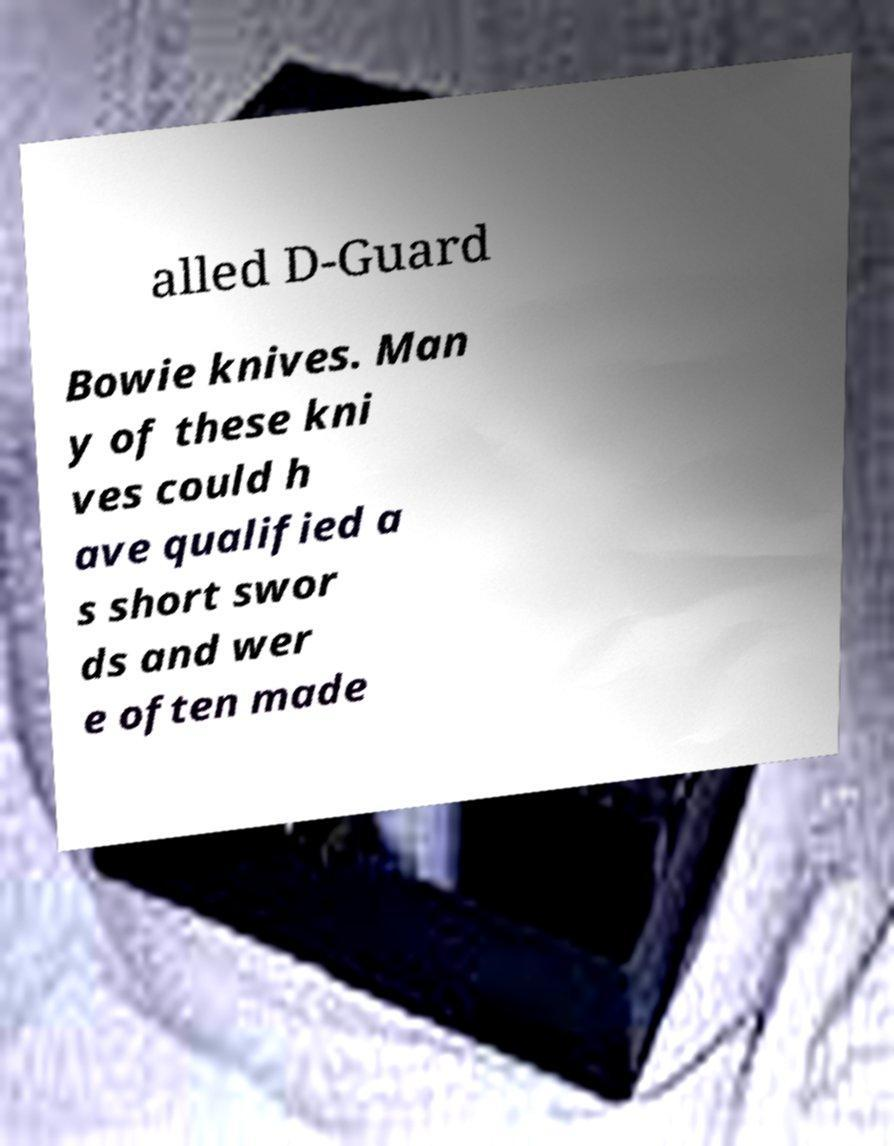I need the written content from this picture converted into text. Can you do that? alled D-Guard Bowie knives. Man y of these kni ves could h ave qualified a s short swor ds and wer e often made 